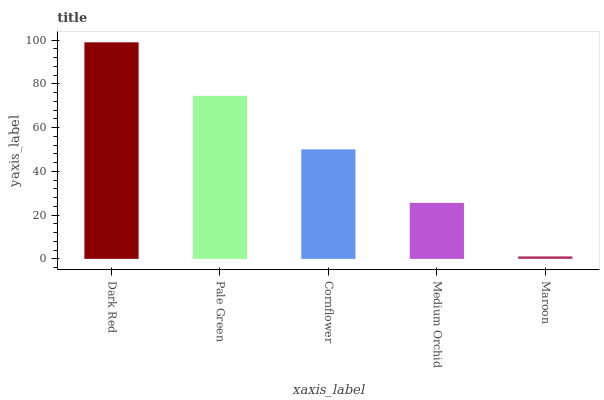Is Maroon the minimum?
Answer yes or no. Yes. Is Dark Red the maximum?
Answer yes or no. Yes. Is Pale Green the minimum?
Answer yes or no. No. Is Pale Green the maximum?
Answer yes or no. No. Is Dark Red greater than Pale Green?
Answer yes or no. Yes. Is Pale Green less than Dark Red?
Answer yes or no. Yes. Is Pale Green greater than Dark Red?
Answer yes or no. No. Is Dark Red less than Pale Green?
Answer yes or no. No. Is Cornflower the high median?
Answer yes or no. Yes. Is Cornflower the low median?
Answer yes or no. Yes. Is Dark Red the high median?
Answer yes or no. No. Is Pale Green the low median?
Answer yes or no. No. 